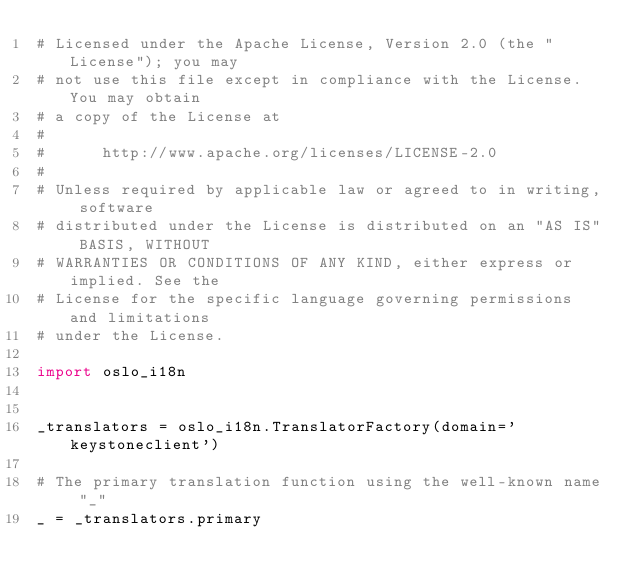<code> <loc_0><loc_0><loc_500><loc_500><_Python_># Licensed under the Apache License, Version 2.0 (the "License"); you may
# not use this file except in compliance with the License. You may obtain
# a copy of the License at
#
#      http://www.apache.org/licenses/LICENSE-2.0
#
# Unless required by applicable law or agreed to in writing, software
# distributed under the License is distributed on an "AS IS" BASIS, WITHOUT
# WARRANTIES OR CONDITIONS OF ANY KIND, either express or implied. See the
# License for the specific language governing permissions and limitations
# under the License.

import oslo_i18n


_translators = oslo_i18n.TranslatorFactory(domain='keystoneclient')

# The primary translation function using the well-known name "_"
_ = _translators.primary
</code> 